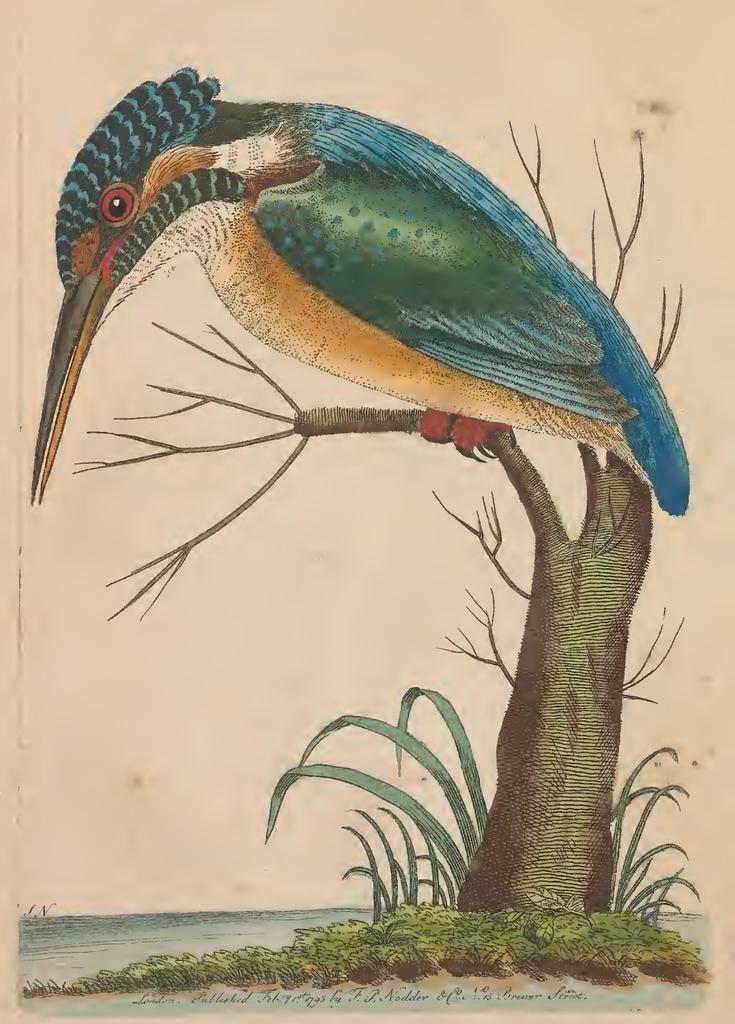Can you describe this image briefly? This image is a painting. In this image there is a tree and we can see a bird on the tree. At the bottom there is grass and we can see water. 